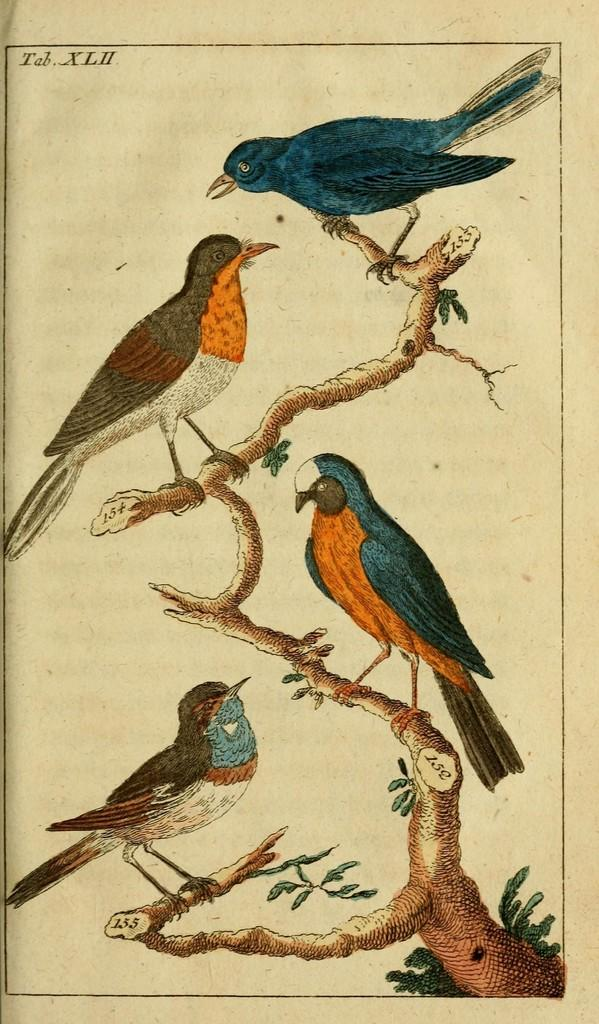What is the main subject of the poster in the image? The main subject of the poster in the image is four birds on a tree stem. Are there any other elements present on the poster besides the birds? Yes, the poster includes leaves. Is there any text visible on the poster? There is text visible at the top of the image. What type of marble is used to create the love-shaped sculpture in the image? There is no love-shaped sculpture or marble present in the image. 